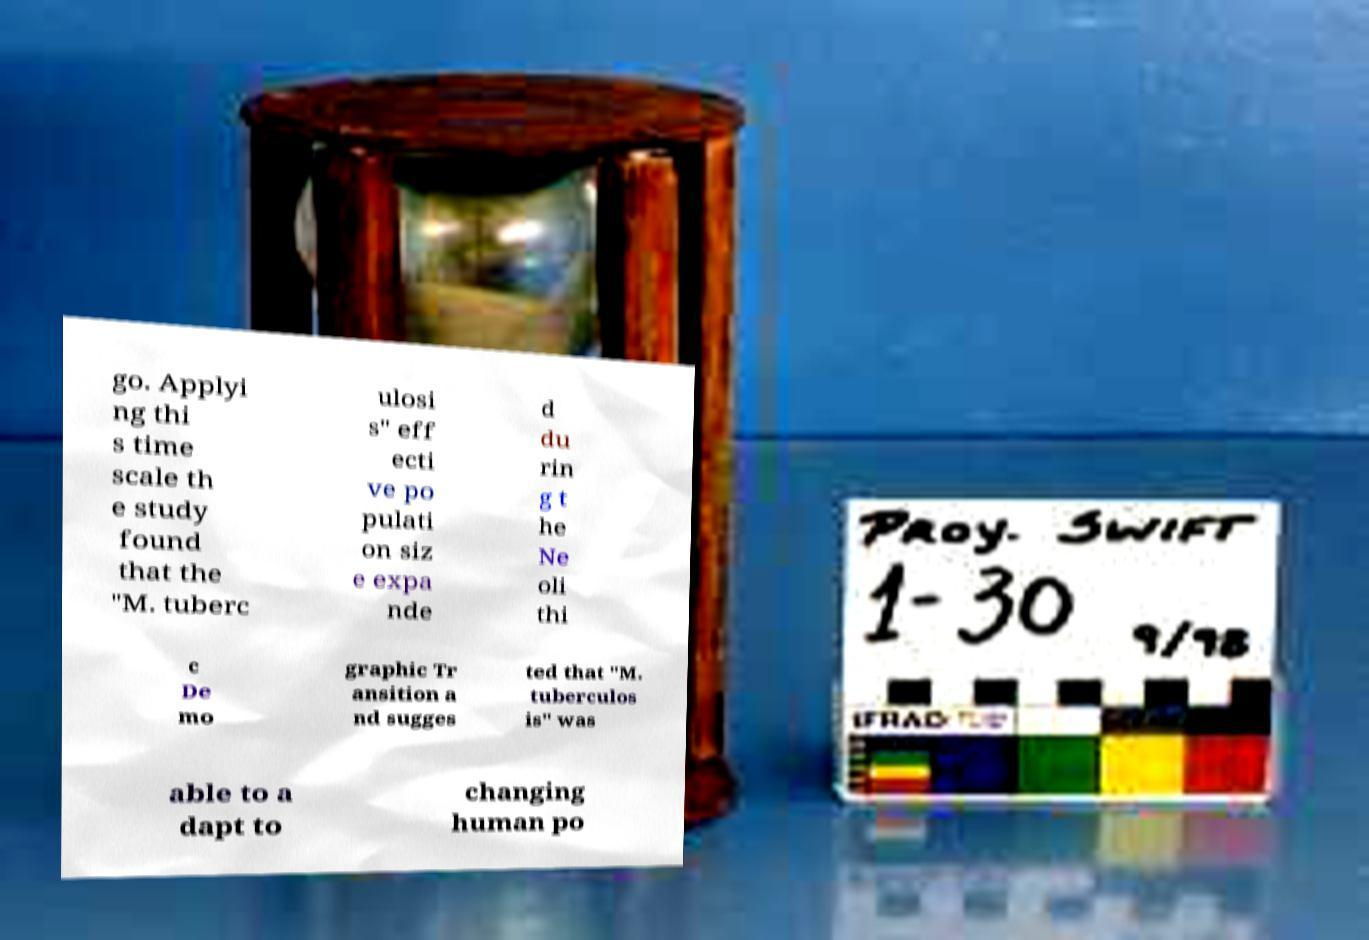Could you assist in decoding the text presented in this image and type it out clearly? go. Applyi ng thi s time scale th e study found that the "M. tuberc ulosi s" eff ecti ve po pulati on siz e expa nde d du rin g t he Ne oli thi c De mo graphic Tr ansition a nd sugges ted that "M. tuberculos is" was able to a dapt to changing human po 